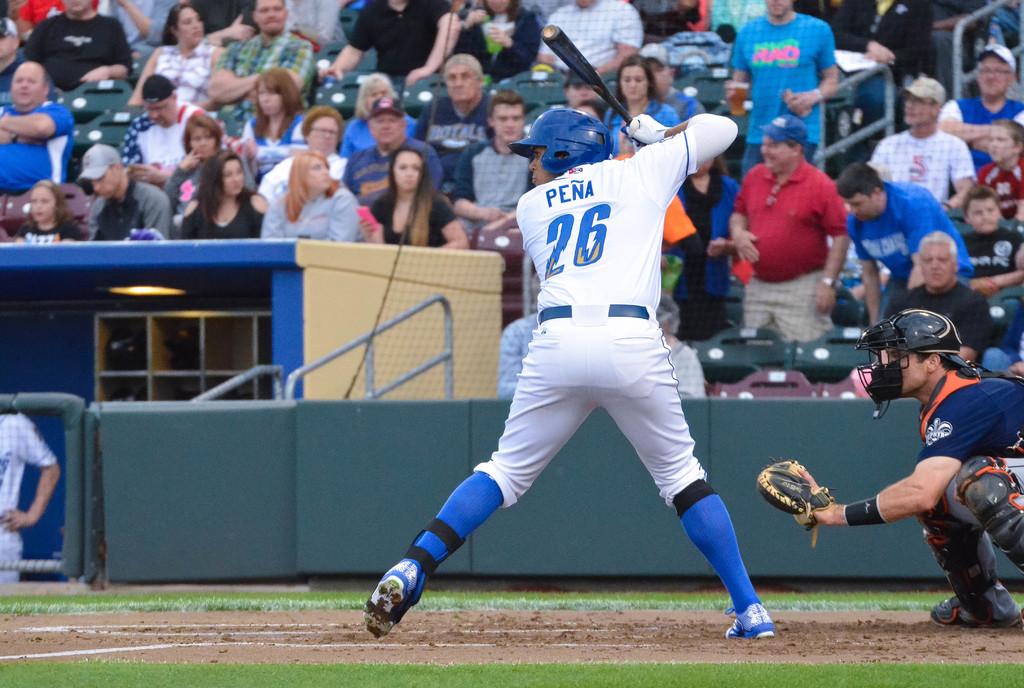What is the batter's number?
Offer a terse response. 26. Whats the name on his shirt?
Provide a short and direct response. Pena. 